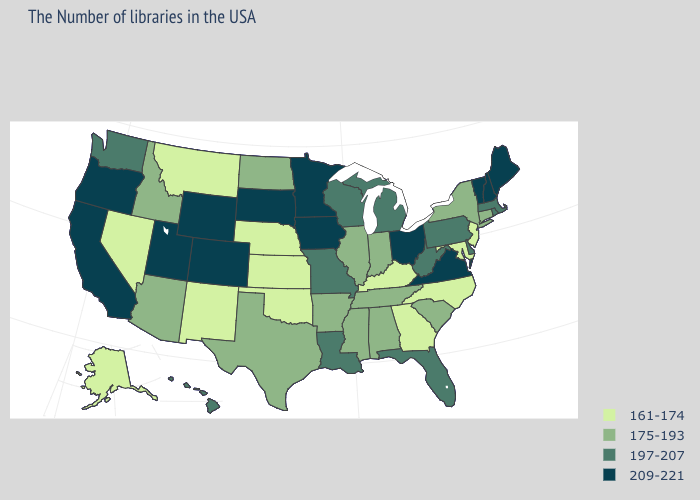Does the map have missing data?
Concise answer only. No. What is the value of Michigan?
Keep it brief. 197-207. What is the highest value in the MidWest ?
Be succinct. 209-221. Name the states that have a value in the range 197-207?
Be succinct. Massachusetts, Rhode Island, Delaware, Pennsylvania, West Virginia, Florida, Michigan, Wisconsin, Louisiana, Missouri, Washington, Hawaii. Does New York have a higher value than Maryland?
Keep it brief. Yes. What is the value of Louisiana?
Be succinct. 197-207. What is the value of Nebraska?
Answer briefly. 161-174. Which states have the highest value in the USA?
Write a very short answer. Maine, New Hampshire, Vermont, Virginia, Ohio, Minnesota, Iowa, South Dakota, Wyoming, Colorado, Utah, California, Oregon. What is the value of Iowa?
Give a very brief answer. 209-221. What is the value of Illinois?
Quick response, please. 175-193. Does the map have missing data?
Answer briefly. No. What is the highest value in the USA?
Be succinct. 209-221. Which states have the highest value in the USA?
Concise answer only. Maine, New Hampshire, Vermont, Virginia, Ohio, Minnesota, Iowa, South Dakota, Wyoming, Colorado, Utah, California, Oregon. Among the states that border New York , which have the lowest value?
Short answer required. New Jersey. Among the states that border Missouri , which have the highest value?
Answer briefly. Iowa. 